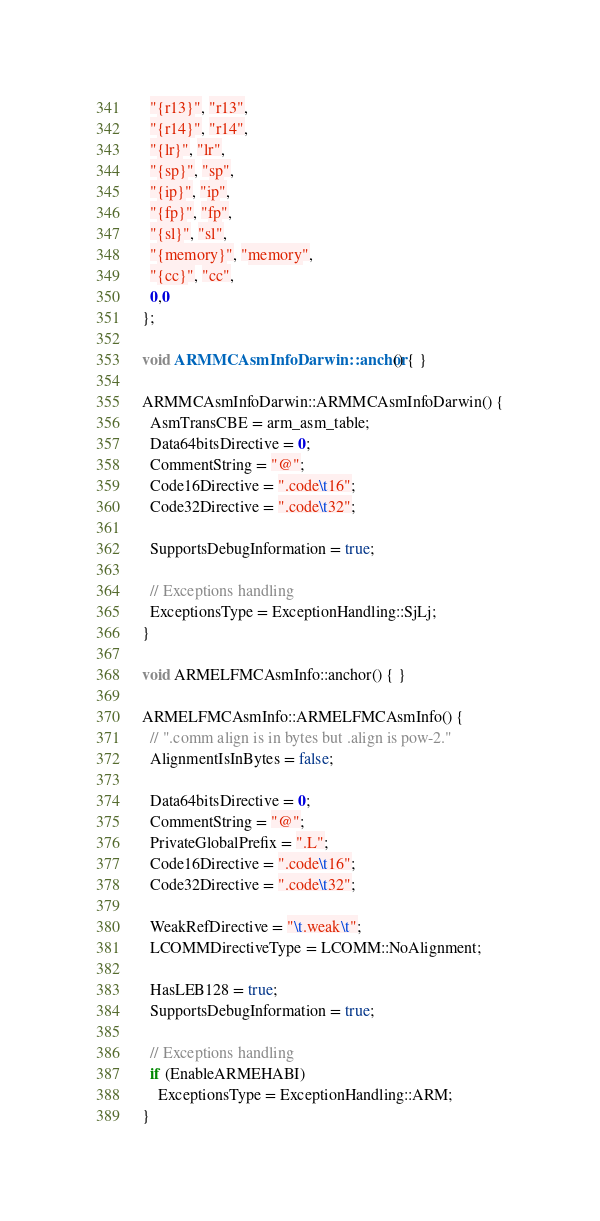Convert code to text. <code><loc_0><loc_0><loc_500><loc_500><_C++_>  "{r13}", "r13",
  "{r14}", "r14",
  "{lr}", "lr",
  "{sp}", "sp",
  "{ip}", "ip",
  "{fp}", "fp",
  "{sl}", "sl",
  "{memory}", "memory",
  "{cc}", "cc",
  0,0
};

void ARMMCAsmInfoDarwin::anchor() { }

ARMMCAsmInfoDarwin::ARMMCAsmInfoDarwin() {
  AsmTransCBE = arm_asm_table;
  Data64bitsDirective = 0;
  CommentString = "@";
  Code16Directive = ".code\t16";
  Code32Directive = ".code\t32";

  SupportsDebugInformation = true;

  // Exceptions handling
  ExceptionsType = ExceptionHandling::SjLj;
}

void ARMELFMCAsmInfo::anchor() { }

ARMELFMCAsmInfo::ARMELFMCAsmInfo() {
  // ".comm align is in bytes but .align is pow-2."
  AlignmentIsInBytes = false;

  Data64bitsDirective = 0;
  CommentString = "@";
  PrivateGlobalPrefix = ".L";
  Code16Directive = ".code\t16";
  Code32Directive = ".code\t32";

  WeakRefDirective = "\t.weak\t";
  LCOMMDirectiveType = LCOMM::NoAlignment;

  HasLEB128 = true;
  SupportsDebugInformation = true;

  // Exceptions handling
  if (EnableARMEHABI)
    ExceptionsType = ExceptionHandling::ARM;
}
</code> 